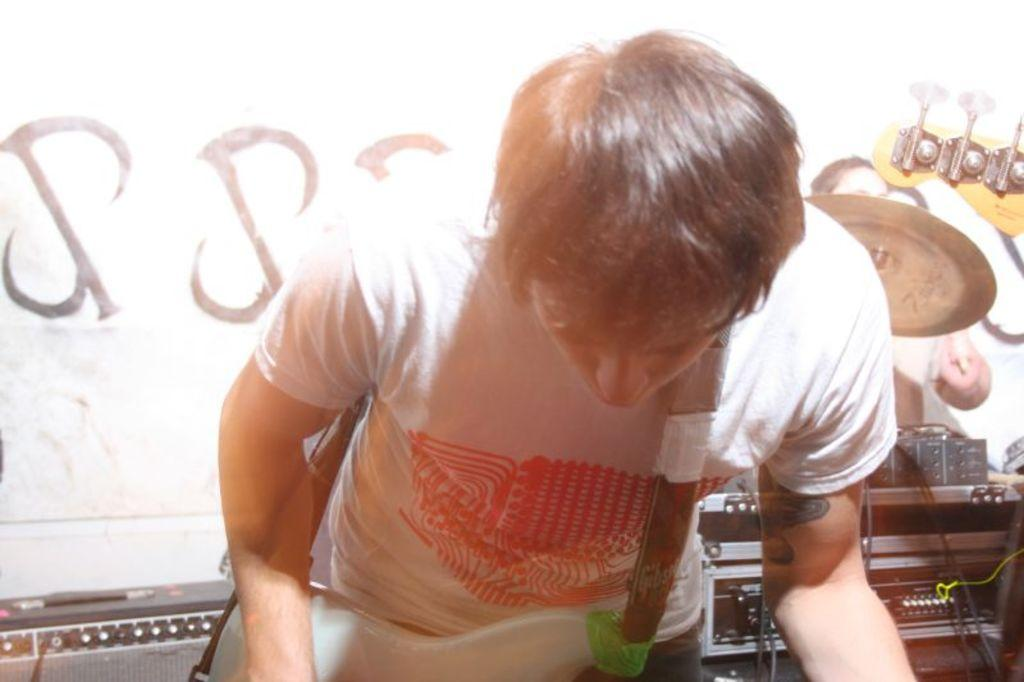Who is present in the image? There is a man in the image. What is the man wearing? The man is wearing a guitar. What can be seen in the background of the image? There are electrical devices and a drum plate in the background. Are there any other people in the image? Yes, there is a person in the background. What type of cap is the coach wearing in the image? There is no coach or cap present in the image. How many threads are visible on the drum plate in the image? There are no threads visible on the drum plate in the image. 